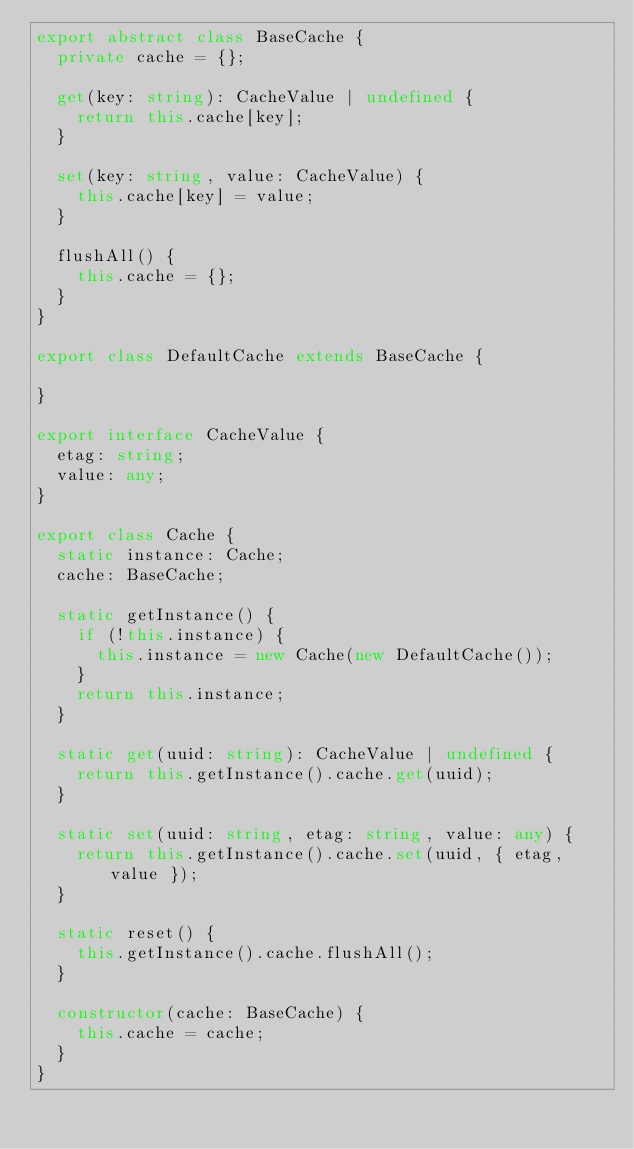<code> <loc_0><loc_0><loc_500><loc_500><_TypeScript_>export abstract class BaseCache {
  private cache = {};

  get(key: string): CacheValue | undefined {
    return this.cache[key];
  }

  set(key: string, value: CacheValue) {
    this.cache[key] = value;
  }

  flushAll() {
    this.cache = {};
  }
}

export class DefaultCache extends BaseCache {

}

export interface CacheValue {
  etag: string;
  value: any;
}

export class Cache {
  static instance: Cache;
  cache: BaseCache;

  static getInstance() {
    if (!this.instance) {
      this.instance = new Cache(new DefaultCache());
    }
    return this.instance;
  }

  static get(uuid: string): CacheValue | undefined {
    return this.getInstance().cache.get(uuid);
  }

  static set(uuid: string, etag: string, value: any) {
    return this.getInstance().cache.set(uuid, { etag, value });
  }

  static reset() {
    this.getInstance().cache.flushAll();
  }

  constructor(cache: BaseCache) {
    this.cache = cache;
  }
}
</code> 